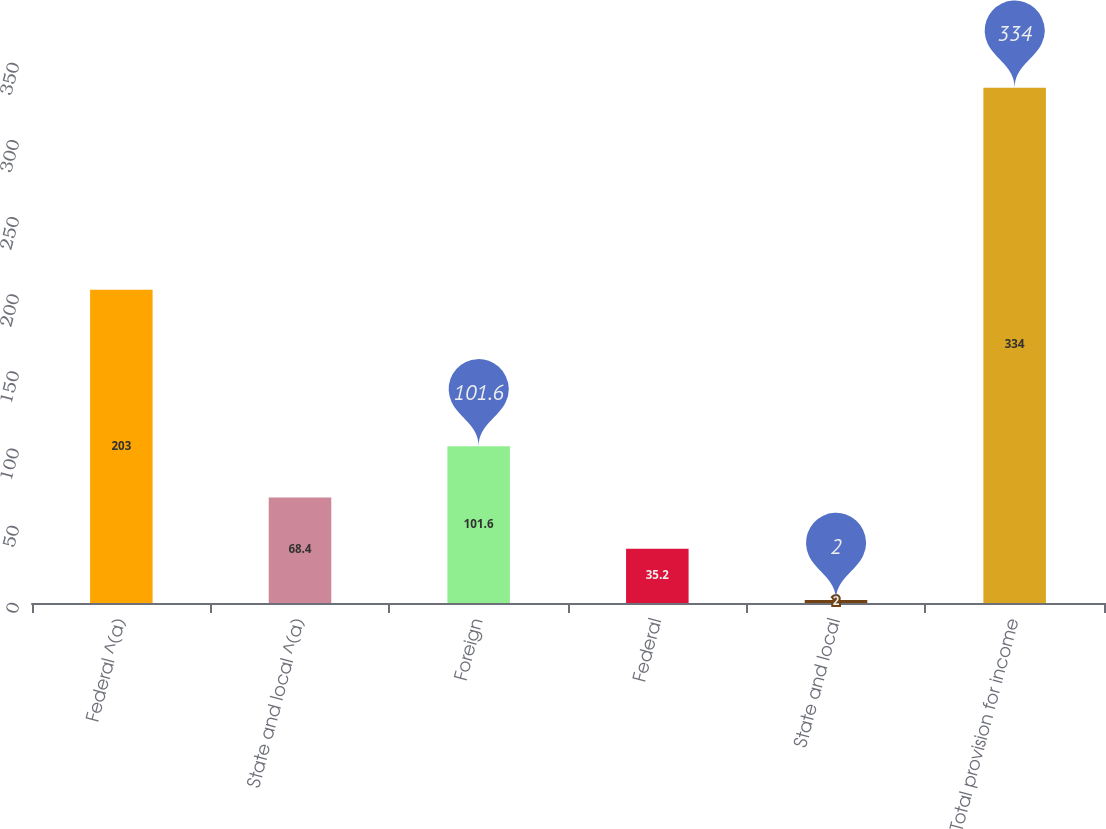Convert chart to OTSL. <chart><loc_0><loc_0><loc_500><loc_500><bar_chart><fcel>Federal ^(a)<fcel>State and local ^(a)<fcel>Foreign<fcel>Federal<fcel>State and local<fcel>Total provision for income<nl><fcel>203<fcel>68.4<fcel>101.6<fcel>35.2<fcel>2<fcel>334<nl></chart> 